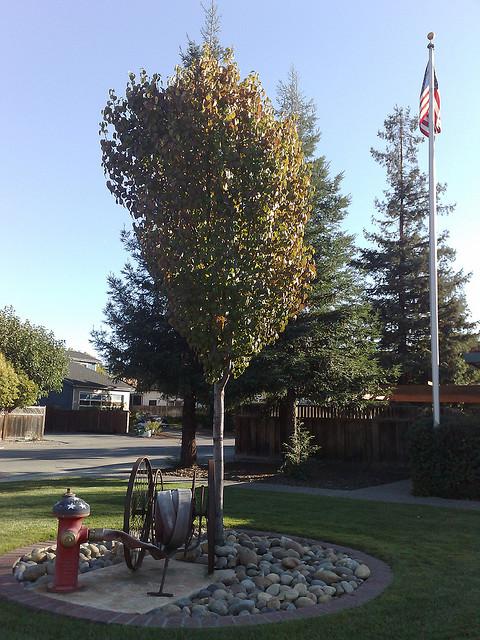Which country's flag is displayed?
Answer briefly. Usa. What is between the tree and the fire hydrant?
Answer briefly. Fire hose. Is the flag at half mast?
Give a very brief answer. No. 